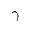Convert formula to latex. <formula><loc_0><loc_0><loc_500><loc_500>\gamma</formula> 